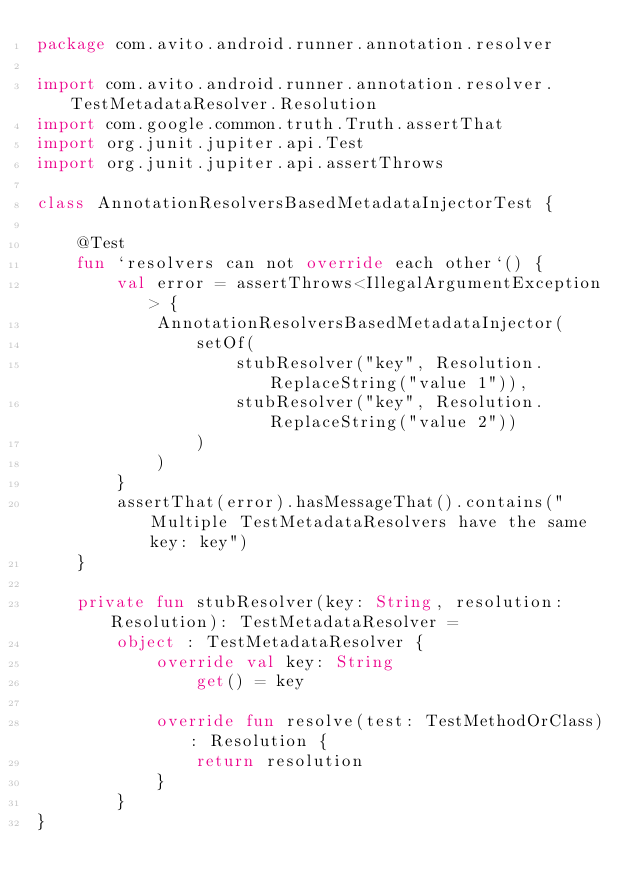<code> <loc_0><loc_0><loc_500><loc_500><_Kotlin_>package com.avito.android.runner.annotation.resolver

import com.avito.android.runner.annotation.resolver.TestMetadataResolver.Resolution
import com.google.common.truth.Truth.assertThat
import org.junit.jupiter.api.Test
import org.junit.jupiter.api.assertThrows

class AnnotationResolversBasedMetadataInjectorTest {

    @Test
    fun `resolvers can not override each other`() {
        val error = assertThrows<IllegalArgumentException> {
            AnnotationResolversBasedMetadataInjector(
                setOf(
                    stubResolver("key", Resolution.ReplaceString("value 1")),
                    stubResolver("key", Resolution.ReplaceString("value 2"))
                )
            )
        }
        assertThat(error).hasMessageThat().contains("Multiple TestMetadataResolvers have the same key: key")
    }

    private fun stubResolver(key: String, resolution: Resolution): TestMetadataResolver =
        object : TestMetadataResolver {
            override val key: String
                get() = key

            override fun resolve(test: TestMethodOrClass): Resolution {
                return resolution
            }
        }
}
</code> 